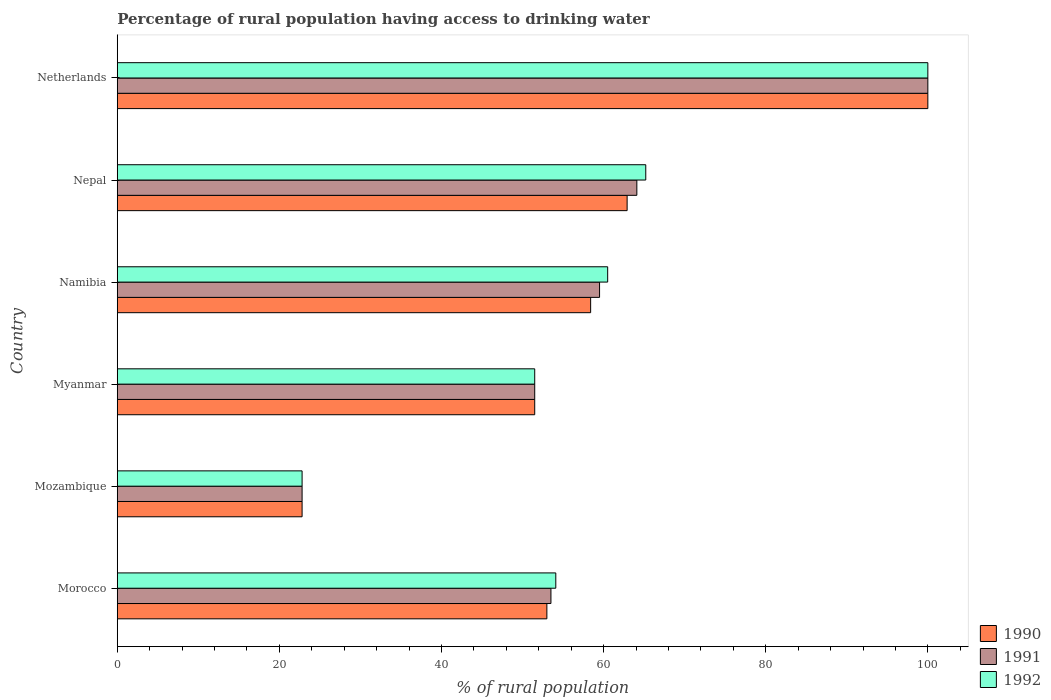How many groups of bars are there?
Offer a very short reply. 6. Are the number of bars per tick equal to the number of legend labels?
Provide a succinct answer. Yes. Are the number of bars on each tick of the Y-axis equal?
Offer a very short reply. Yes. How many bars are there on the 6th tick from the top?
Offer a terse response. 3. How many bars are there on the 5th tick from the bottom?
Make the answer very short. 3. What is the label of the 4th group of bars from the top?
Your answer should be very brief. Myanmar. In how many cases, is the number of bars for a given country not equal to the number of legend labels?
Your response must be concise. 0. What is the percentage of rural population having access to drinking water in 1991 in Mozambique?
Make the answer very short. 22.8. Across all countries, what is the maximum percentage of rural population having access to drinking water in 1992?
Provide a succinct answer. 100. Across all countries, what is the minimum percentage of rural population having access to drinking water in 1992?
Give a very brief answer. 22.8. In which country was the percentage of rural population having access to drinking water in 1992 minimum?
Your answer should be very brief. Mozambique. What is the total percentage of rural population having access to drinking water in 1991 in the graph?
Offer a very short reply. 351.4. What is the difference between the percentage of rural population having access to drinking water in 1992 in Morocco and that in Namibia?
Provide a short and direct response. -6.4. What is the difference between the percentage of rural population having access to drinking water in 1991 in Netherlands and the percentage of rural population having access to drinking water in 1990 in Morocco?
Your answer should be compact. 47. What is the average percentage of rural population having access to drinking water in 1990 per country?
Keep it short and to the point. 58.1. In how many countries, is the percentage of rural population having access to drinking water in 1991 greater than 64 %?
Keep it short and to the point. 2. What is the ratio of the percentage of rural population having access to drinking water in 1991 in Mozambique to that in Myanmar?
Give a very brief answer. 0.44. What is the difference between the highest and the second highest percentage of rural population having access to drinking water in 1990?
Offer a terse response. 37.1. What is the difference between the highest and the lowest percentage of rural population having access to drinking water in 1991?
Keep it short and to the point. 77.2. Is it the case that in every country, the sum of the percentage of rural population having access to drinking water in 1990 and percentage of rural population having access to drinking water in 1991 is greater than the percentage of rural population having access to drinking water in 1992?
Your answer should be very brief. Yes. Are all the bars in the graph horizontal?
Provide a short and direct response. Yes. Does the graph contain grids?
Make the answer very short. No. How many legend labels are there?
Your answer should be very brief. 3. What is the title of the graph?
Make the answer very short. Percentage of rural population having access to drinking water. Does "2009" appear as one of the legend labels in the graph?
Keep it short and to the point. No. What is the label or title of the X-axis?
Your answer should be compact. % of rural population. What is the % of rural population of 1990 in Morocco?
Make the answer very short. 53. What is the % of rural population of 1991 in Morocco?
Your response must be concise. 53.5. What is the % of rural population of 1992 in Morocco?
Offer a very short reply. 54.1. What is the % of rural population in 1990 in Mozambique?
Offer a very short reply. 22.8. What is the % of rural population of 1991 in Mozambique?
Provide a short and direct response. 22.8. What is the % of rural population of 1992 in Mozambique?
Your answer should be compact. 22.8. What is the % of rural population in 1990 in Myanmar?
Provide a succinct answer. 51.5. What is the % of rural population in 1991 in Myanmar?
Offer a terse response. 51.5. What is the % of rural population of 1992 in Myanmar?
Offer a very short reply. 51.5. What is the % of rural population in 1990 in Namibia?
Your answer should be very brief. 58.4. What is the % of rural population of 1991 in Namibia?
Your response must be concise. 59.5. What is the % of rural population in 1992 in Namibia?
Provide a succinct answer. 60.5. What is the % of rural population of 1990 in Nepal?
Offer a very short reply. 62.9. What is the % of rural population of 1991 in Nepal?
Make the answer very short. 64.1. What is the % of rural population of 1992 in Nepal?
Your answer should be compact. 65.2. What is the % of rural population in 1990 in Netherlands?
Offer a terse response. 100. Across all countries, what is the maximum % of rural population of 1990?
Provide a short and direct response. 100. Across all countries, what is the maximum % of rural population of 1991?
Give a very brief answer. 100. Across all countries, what is the maximum % of rural population in 1992?
Give a very brief answer. 100. Across all countries, what is the minimum % of rural population of 1990?
Make the answer very short. 22.8. Across all countries, what is the minimum % of rural population of 1991?
Make the answer very short. 22.8. Across all countries, what is the minimum % of rural population of 1992?
Keep it short and to the point. 22.8. What is the total % of rural population of 1990 in the graph?
Provide a short and direct response. 348.6. What is the total % of rural population in 1991 in the graph?
Ensure brevity in your answer.  351.4. What is the total % of rural population in 1992 in the graph?
Offer a terse response. 354.1. What is the difference between the % of rural population in 1990 in Morocco and that in Mozambique?
Your answer should be very brief. 30.2. What is the difference between the % of rural population in 1991 in Morocco and that in Mozambique?
Give a very brief answer. 30.7. What is the difference between the % of rural population of 1992 in Morocco and that in Mozambique?
Offer a terse response. 31.3. What is the difference between the % of rural population of 1991 in Morocco and that in Myanmar?
Ensure brevity in your answer.  2. What is the difference between the % of rural population of 1992 in Morocco and that in Myanmar?
Ensure brevity in your answer.  2.6. What is the difference between the % of rural population of 1990 in Morocco and that in Namibia?
Offer a very short reply. -5.4. What is the difference between the % of rural population of 1992 in Morocco and that in Namibia?
Make the answer very short. -6.4. What is the difference between the % of rural population of 1990 in Morocco and that in Nepal?
Give a very brief answer. -9.9. What is the difference between the % of rural population in 1992 in Morocco and that in Nepal?
Offer a terse response. -11.1. What is the difference between the % of rural population of 1990 in Morocco and that in Netherlands?
Provide a succinct answer. -47. What is the difference between the % of rural population of 1991 in Morocco and that in Netherlands?
Offer a terse response. -46.5. What is the difference between the % of rural population of 1992 in Morocco and that in Netherlands?
Your answer should be compact. -45.9. What is the difference between the % of rural population of 1990 in Mozambique and that in Myanmar?
Provide a succinct answer. -28.7. What is the difference between the % of rural population in 1991 in Mozambique and that in Myanmar?
Ensure brevity in your answer.  -28.7. What is the difference between the % of rural population of 1992 in Mozambique and that in Myanmar?
Your response must be concise. -28.7. What is the difference between the % of rural population of 1990 in Mozambique and that in Namibia?
Offer a terse response. -35.6. What is the difference between the % of rural population of 1991 in Mozambique and that in Namibia?
Make the answer very short. -36.7. What is the difference between the % of rural population of 1992 in Mozambique and that in Namibia?
Ensure brevity in your answer.  -37.7. What is the difference between the % of rural population in 1990 in Mozambique and that in Nepal?
Your answer should be very brief. -40.1. What is the difference between the % of rural population in 1991 in Mozambique and that in Nepal?
Your answer should be compact. -41.3. What is the difference between the % of rural population in 1992 in Mozambique and that in Nepal?
Offer a terse response. -42.4. What is the difference between the % of rural population in 1990 in Mozambique and that in Netherlands?
Your response must be concise. -77.2. What is the difference between the % of rural population in 1991 in Mozambique and that in Netherlands?
Give a very brief answer. -77.2. What is the difference between the % of rural population of 1992 in Mozambique and that in Netherlands?
Your answer should be compact. -77.2. What is the difference between the % of rural population of 1990 in Myanmar and that in Namibia?
Provide a short and direct response. -6.9. What is the difference between the % of rural population in 1992 in Myanmar and that in Namibia?
Provide a succinct answer. -9. What is the difference between the % of rural population of 1990 in Myanmar and that in Nepal?
Keep it short and to the point. -11.4. What is the difference between the % of rural population of 1992 in Myanmar and that in Nepal?
Make the answer very short. -13.7. What is the difference between the % of rural population of 1990 in Myanmar and that in Netherlands?
Your answer should be compact. -48.5. What is the difference between the % of rural population of 1991 in Myanmar and that in Netherlands?
Give a very brief answer. -48.5. What is the difference between the % of rural population in 1992 in Myanmar and that in Netherlands?
Ensure brevity in your answer.  -48.5. What is the difference between the % of rural population in 1991 in Namibia and that in Nepal?
Offer a very short reply. -4.6. What is the difference between the % of rural population in 1992 in Namibia and that in Nepal?
Make the answer very short. -4.7. What is the difference between the % of rural population in 1990 in Namibia and that in Netherlands?
Your answer should be compact. -41.6. What is the difference between the % of rural population in 1991 in Namibia and that in Netherlands?
Your response must be concise. -40.5. What is the difference between the % of rural population in 1992 in Namibia and that in Netherlands?
Offer a very short reply. -39.5. What is the difference between the % of rural population in 1990 in Nepal and that in Netherlands?
Your answer should be compact. -37.1. What is the difference between the % of rural population of 1991 in Nepal and that in Netherlands?
Offer a very short reply. -35.9. What is the difference between the % of rural population in 1992 in Nepal and that in Netherlands?
Make the answer very short. -34.8. What is the difference between the % of rural population of 1990 in Morocco and the % of rural population of 1991 in Mozambique?
Your answer should be very brief. 30.2. What is the difference between the % of rural population in 1990 in Morocco and the % of rural population in 1992 in Mozambique?
Make the answer very short. 30.2. What is the difference between the % of rural population in 1991 in Morocco and the % of rural population in 1992 in Mozambique?
Offer a terse response. 30.7. What is the difference between the % of rural population in 1990 in Morocco and the % of rural population in 1991 in Myanmar?
Give a very brief answer. 1.5. What is the difference between the % of rural population in 1990 in Morocco and the % of rural population in 1992 in Namibia?
Your answer should be compact. -7.5. What is the difference between the % of rural population of 1991 in Morocco and the % of rural population of 1992 in Namibia?
Offer a very short reply. -7. What is the difference between the % of rural population in 1991 in Morocco and the % of rural population in 1992 in Nepal?
Give a very brief answer. -11.7. What is the difference between the % of rural population of 1990 in Morocco and the % of rural population of 1991 in Netherlands?
Give a very brief answer. -47. What is the difference between the % of rural population in 1990 in Morocco and the % of rural population in 1992 in Netherlands?
Ensure brevity in your answer.  -47. What is the difference between the % of rural population of 1991 in Morocco and the % of rural population of 1992 in Netherlands?
Provide a short and direct response. -46.5. What is the difference between the % of rural population of 1990 in Mozambique and the % of rural population of 1991 in Myanmar?
Your answer should be very brief. -28.7. What is the difference between the % of rural population of 1990 in Mozambique and the % of rural population of 1992 in Myanmar?
Your answer should be very brief. -28.7. What is the difference between the % of rural population in 1991 in Mozambique and the % of rural population in 1992 in Myanmar?
Ensure brevity in your answer.  -28.7. What is the difference between the % of rural population in 1990 in Mozambique and the % of rural population in 1991 in Namibia?
Offer a terse response. -36.7. What is the difference between the % of rural population of 1990 in Mozambique and the % of rural population of 1992 in Namibia?
Provide a succinct answer. -37.7. What is the difference between the % of rural population of 1991 in Mozambique and the % of rural population of 1992 in Namibia?
Provide a succinct answer. -37.7. What is the difference between the % of rural population in 1990 in Mozambique and the % of rural population in 1991 in Nepal?
Ensure brevity in your answer.  -41.3. What is the difference between the % of rural population of 1990 in Mozambique and the % of rural population of 1992 in Nepal?
Give a very brief answer. -42.4. What is the difference between the % of rural population of 1991 in Mozambique and the % of rural population of 1992 in Nepal?
Offer a terse response. -42.4. What is the difference between the % of rural population of 1990 in Mozambique and the % of rural population of 1991 in Netherlands?
Your response must be concise. -77.2. What is the difference between the % of rural population of 1990 in Mozambique and the % of rural population of 1992 in Netherlands?
Make the answer very short. -77.2. What is the difference between the % of rural population in 1991 in Mozambique and the % of rural population in 1992 in Netherlands?
Your answer should be compact. -77.2. What is the difference between the % of rural population of 1990 in Myanmar and the % of rural population of 1992 in Namibia?
Make the answer very short. -9. What is the difference between the % of rural population in 1990 in Myanmar and the % of rural population in 1991 in Nepal?
Provide a succinct answer. -12.6. What is the difference between the % of rural population of 1990 in Myanmar and the % of rural population of 1992 in Nepal?
Make the answer very short. -13.7. What is the difference between the % of rural population of 1991 in Myanmar and the % of rural population of 1992 in Nepal?
Give a very brief answer. -13.7. What is the difference between the % of rural population of 1990 in Myanmar and the % of rural population of 1991 in Netherlands?
Provide a succinct answer. -48.5. What is the difference between the % of rural population in 1990 in Myanmar and the % of rural population in 1992 in Netherlands?
Provide a short and direct response. -48.5. What is the difference between the % of rural population of 1991 in Myanmar and the % of rural population of 1992 in Netherlands?
Provide a short and direct response. -48.5. What is the difference between the % of rural population in 1990 in Namibia and the % of rural population in 1991 in Nepal?
Your response must be concise. -5.7. What is the difference between the % of rural population of 1991 in Namibia and the % of rural population of 1992 in Nepal?
Your answer should be very brief. -5.7. What is the difference between the % of rural population of 1990 in Namibia and the % of rural population of 1991 in Netherlands?
Give a very brief answer. -41.6. What is the difference between the % of rural population in 1990 in Namibia and the % of rural population in 1992 in Netherlands?
Keep it short and to the point. -41.6. What is the difference between the % of rural population in 1991 in Namibia and the % of rural population in 1992 in Netherlands?
Ensure brevity in your answer.  -40.5. What is the difference between the % of rural population of 1990 in Nepal and the % of rural population of 1991 in Netherlands?
Offer a very short reply. -37.1. What is the difference between the % of rural population of 1990 in Nepal and the % of rural population of 1992 in Netherlands?
Offer a terse response. -37.1. What is the difference between the % of rural population of 1991 in Nepal and the % of rural population of 1992 in Netherlands?
Ensure brevity in your answer.  -35.9. What is the average % of rural population of 1990 per country?
Your response must be concise. 58.1. What is the average % of rural population of 1991 per country?
Your response must be concise. 58.57. What is the average % of rural population of 1992 per country?
Offer a very short reply. 59.02. What is the difference between the % of rural population in 1990 and % of rural population in 1991 in Morocco?
Your answer should be very brief. -0.5. What is the difference between the % of rural population of 1990 and % of rural population of 1992 in Morocco?
Your answer should be very brief. -1.1. What is the difference between the % of rural population of 1990 and % of rural population of 1991 in Mozambique?
Your response must be concise. 0. What is the difference between the % of rural population in 1990 and % of rural population in 1992 in Namibia?
Your answer should be very brief. -2.1. What is the difference between the % of rural population of 1991 and % of rural population of 1992 in Namibia?
Your response must be concise. -1. What is the difference between the % of rural population in 1990 and % of rural population in 1991 in Nepal?
Make the answer very short. -1.2. What is the difference between the % of rural population of 1990 and % of rural population of 1991 in Netherlands?
Your answer should be very brief. 0. What is the difference between the % of rural population of 1990 and % of rural population of 1992 in Netherlands?
Keep it short and to the point. 0. What is the difference between the % of rural population in 1991 and % of rural population in 1992 in Netherlands?
Your answer should be very brief. 0. What is the ratio of the % of rural population in 1990 in Morocco to that in Mozambique?
Your answer should be compact. 2.32. What is the ratio of the % of rural population in 1991 in Morocco to that in Mozambique?
Make the answer very short. 2.35. What is the ratio of the % of rural population in 1992 in Morocco to that in Mozambique?
Make the answer very short. 2.37. What is the ratio of the % of rural population in 1990 in Morocco to that in Myanmar?
Give a very brief answer. 1.03. What is the ratio of the % of rural population in 1991 in Morocco to that in Myanmar?
Make the answer very short. 1.04. What is the ratio of the % of rural population in 1992 in Morocco to that in Myanmar?
Your response must be concise. 1.05. What is the ratio of the % of rural population of 1990 in Morocco to that in Namibia?
Keep it short and to the point. 0.91. What is the ratio of the % of rural population in 1991 in Morocco to that in Namibia?
Provide a succinct answer. 0.9. What is the ratio of the % of rural population in 1992 in Morocco to that in Namibia?
Your answer should be compact. 0.89. What is the ratio of the % of rural population of 1990 in Morocco to that in Nepal?
Keep it short and to the point. 0.84. What is the ratio of the % of rural population of 1991 in Morocco to that in Nepal?
Offer a terse response. 0.83. What is the ratio of the % of rural population in 1992 in Morocco to that in Nepal?
Your answer should be very brief. 0.83. What is the ratio of the % of rural population in 1990 in Morocco to that in Netherlands?
Your answer should be very brief. 0.53. What is the ratio of the % of rural population of 1991 in Morocco to that in Netherlands?
Offer a terse response. 0.54. What is the ratio of the % of rural population in 1992 in Morocco to that in Netherlands?
Provide a short and direct response. 0.54. What is the ratio of the % of rural population in 1990 in Mozambique to that in Myanmar?
Your response must be concise. 0.44. What is the ratio of the % of rural population of 1991 in Mozambique to that in Myanmar?
Keep it short and to the point. 0.44. What is the ratio of the % of rural population of 1992 in Mozambique to that in Myanmar?
Your response must be concise. 0.44. What is the ratio of the % of rural population of 1990 in Mozambique to that in Namibia?
Your answer should be very brief. 0.39. What is the ratio of the % of rural population in 1991 in Mozambique to that in Namibia?
Offer a very short reply. 0.38. What is the ratio of the % of rural population in 1992 in Mozambique to that in Namibia?
Ensure brevity in your answer.  0.38. What is the ratio of the % of rural population in 1990 in Mozambique to that in Nepal?
Your answer should be compact. 0.36. What is the ratio of the % of rural population in 1991 in Mozambique to that in Nepal?
Provide a short and direct response. 0.36. What is the ratio of the % of rural population in 1992 in Mozambique to that in Nepal?
Provide a short and direct response. 0.35. What is the ratio of the % of rural population in 1990 in Mozambique to that in Netherlands?
Offer a terse response. 0.23. What is the ratio of the % of rural population in 1991 in Mozambique to that in Netherlands?
Give a very brief answer. 0.23. What is the ratio of the % of rural population in 1992 in Mozambique to that in Netherlands?
Provide a succinct answer. 0.23. What is the ratio of the % of rural population of 1990 in Myanmar to that in Namibia?
Keep it short and to the point. 0.88. What is the ratio of the % of rural population of 1991 in Myanmar to that in Namibia?
Offer a terse response. 0.87. What is the ratio of the % of rural population of 1992 in Myanmar to that in Namibia?
Ensure brevity in your answer.  0.85. What is the ratio of the % of rural population in 1990 in Myanmar to that in Nepal?
Provide a succinct answer. 0.82. What is the ratio of the % of rural population of 1991 in Myanmar to that in Nepal?
Ensure brevity in your answer.  0.8. What is the ratio of the % of rural population in 1992 in Myanmar to that in Nepal?
Ensure brevity in your answer.  0.79. What is the ratio of the % of rural population in 1990 in Myanmar to that in Netherlands?
Your answer should be compact. 0.52. What is the ratio of the % of rural population in 1991 in Myanmar to that in Netherlands?
Give a very brief answer. 0.52. What is the ratio of the % of rural population of 1992 in Myanmar to that in Netherlands?
Your answer should be compact. 0.52. What is the ratio of the % of rural population in 1990 in Namibia to that in Nepal?
Offer a very short reply. 0.93. What is the ratio of the % of rural population of 1991 in Namibia to that in Nepal?
Ensure brevity in your answer.  0.93. What is the ratio of the % of rural population of 1992 in Namibia to that in Nepal?
Your response must be concise. 0.93. What is the ratio of the % of rural population in 1990 in Namibia to that in Netherlands?
Your response must be concise. 0.58. What is the ratio of the % of rural population in 1991 in Namibia to that in Netherlands?
Keep it short and to the point. 0.59. What is the ratio of the % of rural population in 1992 in Namibia to that in Netherlands?
Provide a short and direct response. 0.6. What is the ratio of the % of rural population of 1990 in Nepal to that in Netherlands?
Ensure brevity in your answer.  0.63. What is the ratio of the % of rural population of 1991 in Nepal to that in Netherlands?
Give a very brief answer. 0.64. What is the ratio of the % of rural population in 1992 in Nepal to that in Netherlands?
Offer a terse response. 0.65. What is the difference between the highest and the second highest % of rural population in 1990?
Provide a short and direct response. 37.1. What is the difference between the highest and the second highest % of rural population of 1991?
Offer a terse response. 35.9. What is the difference between the highest and the second highest % of rural population of 1992?
Provide a short and direct response. 34.8. What is the difference between the highest and the lowest % of rural population of 1990?
Your answer should be compact. 77.2. What is the difference between the highest and the lowest % of rural population of 1991?
Keep it short and to the point. 77.2. What is the difference between the highest and the lowest % of rural population of 1992?
Ensure brevity in your answer.  77.2. 